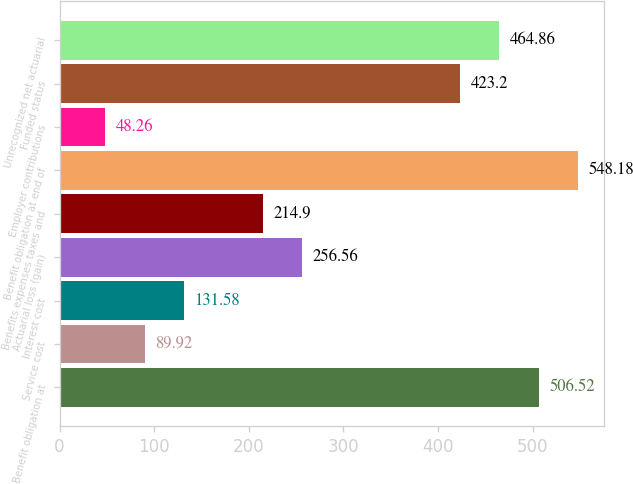<chart> <loc_0><loc_0><loc_500><loc_500><bar_chart><fcel>Benefit obligation at<fcel>Service cost<fcel>Interest cost<fcel>Actuarial loss (gain)<fcel>Benefits expenses taxes and<fcel>Benefit obligation at end of<fcel>Employer contributions<fcel>Funded status<fcel>Unrecognized net actuarial<nl><fcel>506.52<fcel>89.92<fcel>131.58<fcel>256.56<fcel>214.9<fcel>548.18<fcel>48.26<fcel>423.2<fcel>464.86<nl></chart> 